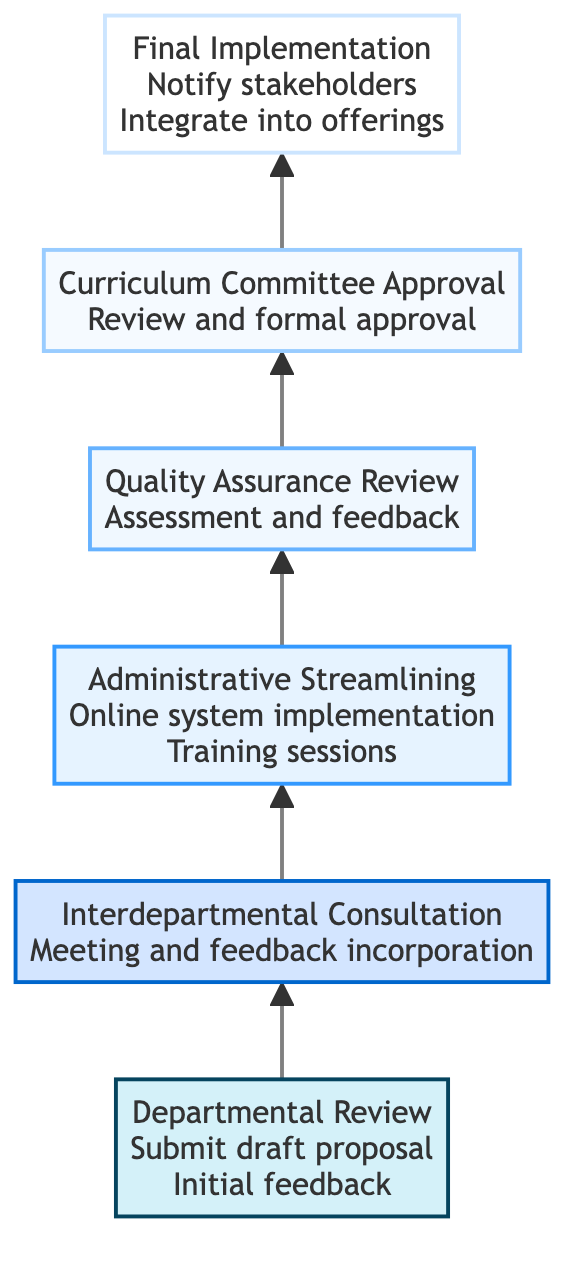What is the first step in the curriculum approval process? The diagram indicates that the first step is "Departmental Review," highlighted as the lowest node in the flow.
Answer: Departmental Review How many levels are there in the curriculum approval process? The diagram shows a total of six levels, labeled from Departmental Review to Final Implementation.
Answer: Six Which step involves interdepartmental meetings? The second step, "Interdepartmental Consultation," specifically mentions meetings with other departments for curriculum alignment.
Answer: Interdepartmental Consultation What are the actions taken during "Quality Assurance Review"? The actions listed include "Quality assessment" and "Feedback for improvements," which are crucial for maintaining educational standards.
Answer: Quality assessment, Feedback for improvements What comes after "Administrative Streamlining" in the process? Following "Administrative Streamlining," the next step in the flow is "Quality Assurance Review," indicating the sequential nature of the process.
Answer: Quality Assurance Review How does the diagram represent the flow of processes? The flow is depicted as a bottom-to-top direction, with arrows pointing upwards to indicate the sequence from the initial review to final implementation.
Answer: Bottom-to-top flow What action is performed at the final level? The final action includes notifying faculty and students and integrating the approved curriculum into the course offerings.
Answer: Notify faculty and students, Integrate into course offerings Which level is characterized by implementing an online submission system? The "Administrative Streamlining" level focuses on implementing an online system to simplify the approval process.
Answer: Administrative Streamlining How many actions are associated with "Curriculum Committee Approval"? There are two actions: "Review by committee" and "Formal approval or revision request," indicating the outcomes of this review process.
Answer: Two actions 